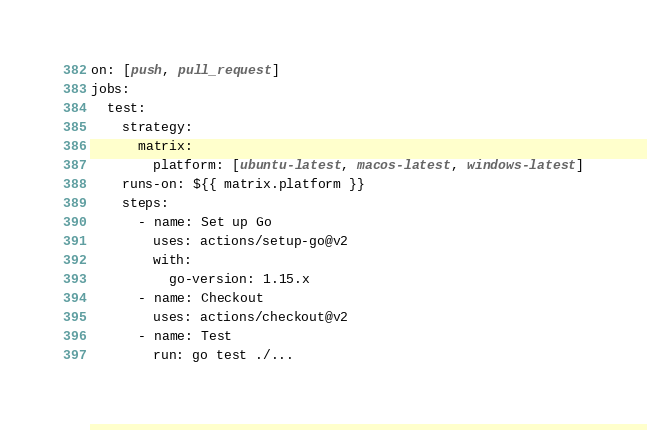Convert code to text. <code><loc_0><loc_0><loc_500><loc_500><_YAML_>on: [push, pull_request]
jobs:
  test:
    strategy:
      matrix:
        platform: [ubuntu-latest, macos-latest, windows-latest]
    runs-on: ${{ matrix.platform }}
    steps:
      - name: Set up Go
        uses: actions/setup-go@v2
        with:
          go-version: 1.15.x
      - name: Checkout
        uses: actions/checkout@v2
      - name: Test
        run: go test ./...</code> 